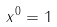<formula> <loc_0><loc_0><loc_500><loc_500>x ^ { 0 } = 1</formula> 